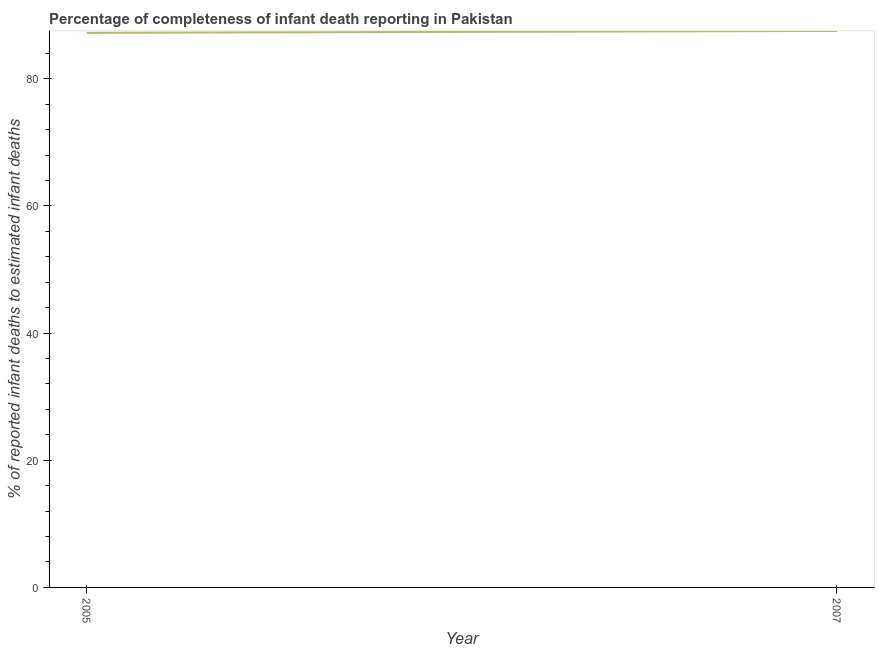What is the completeness of infant death reporting in 2007?
Your response must be concise. 87.51. Across all years, what is the maximum completeness of infant death reporting?
Provide a succinct answer. 87.51. Across all years, what is the minimum completeness of infant death reporting?
Ensure brevity in your answer.  87.21. In which year was the completeness of infant death reporting maximum?
Make the answer very short. 2007. In which year was the completeness of infant death reporting minimum?
Your response must be concise. 2005. What is the sum of the completeness of infant death reporting?
Make the answer very short. 174.72. What is the difference between the completeness of infant death reporting in 2005 and 2007?
Offer a very short reply. -0.31. What is the average completeness of infant death reporting per year?
Your answer should be compact. 87.36. What is the median completeness of infant death reporting?
Ensure brevity in your answer.  87.36. In how many years, is the completeness of infant death reporting greater than 72 %?
Give a very brief answer. 2. What is the ratio of the completeness of infant death reporting in 2005 to that in 2007?
Ensure brevity in your answer.  1. In how many years, is the completeness of infant death reporting greater than the average completeness of infant death reporting taken over all years?
Give a very brief answer. 1. How many lines are there?
Offer a terse response. 1. How many years are there in the graph?
Offer a terse response. 2. What is the difference between two consecutive major ticks on the Y-axis?
Ensure brevity in your answer.  20. Are the values on the major ticks of Y-axis written in scientific E-notation?
Your response must be concise. No. What is the title of the graph?
Your answer should be very brief. Percentage of completeness of infant death reporting in Pakistan. What is the label or title of the Y-axis?
Give a very brief answer. % of reported infant deaths to estimated infant deaths. What is the % of reported infant deaths to estimated infant deaths of 2005?
Your answer should be very brief. 87.21. What is the % of reported infant deaths to estimated infant deaths of 2007?
Your answer should be very brief. 87.51. What is the difference between the % of reported infant deaths to estimated infant deaths in 2005 and 2007?
Your answer should be very brief. -0.31. What is the ratio of the % of reported infant deaths to estimated infant deaths in 2005 to that in 2007?
Provide a short and direct response. 1. 